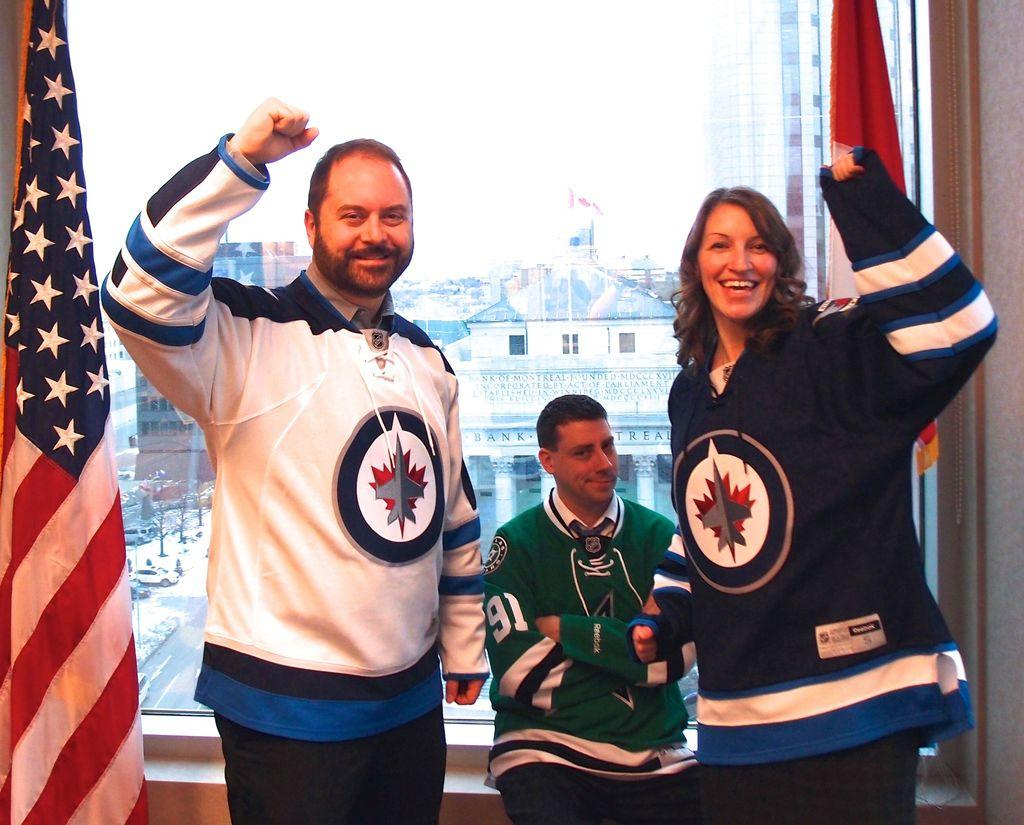<image>
Describe the image concisely. A tiny man wearing a Reebok jersey sits between two celebrating people. 